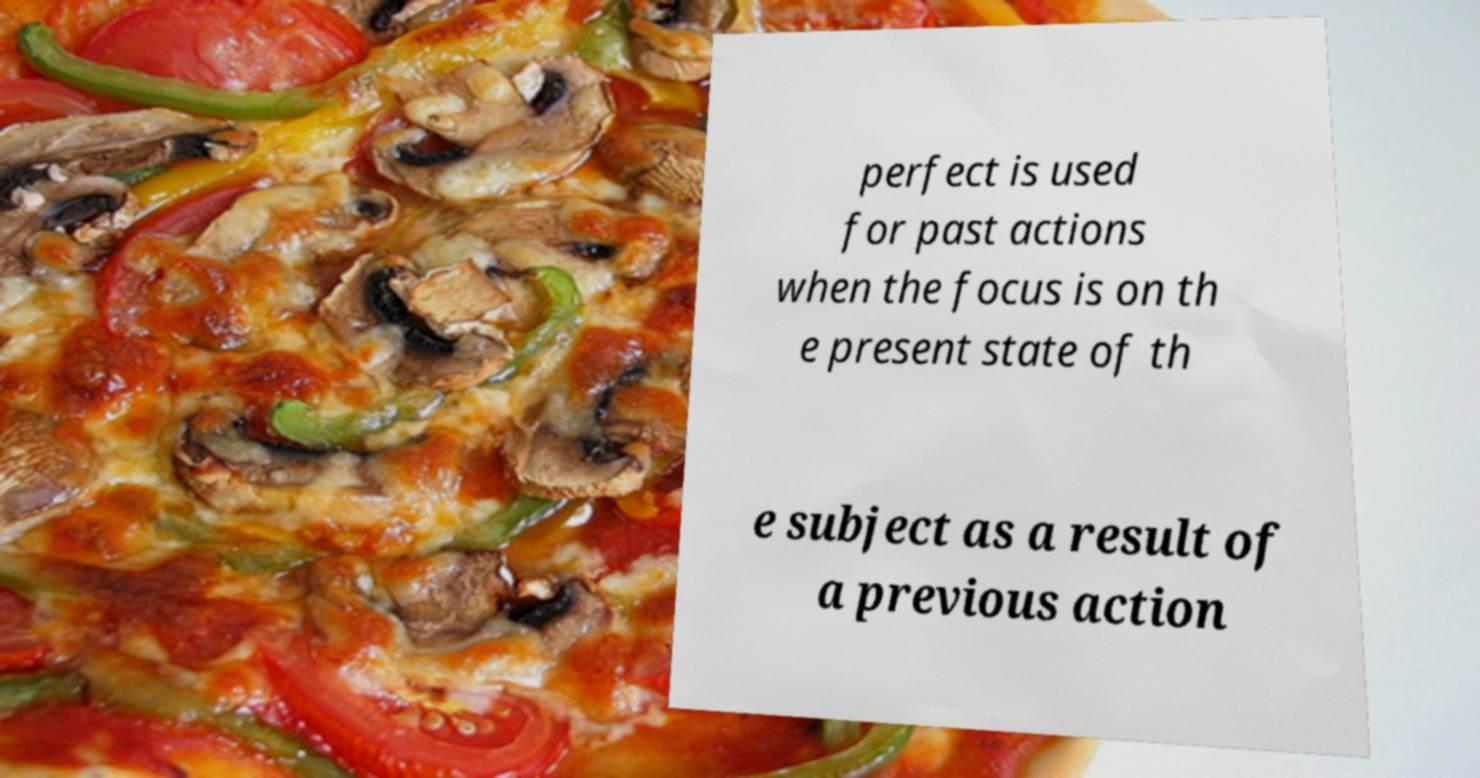There's text embedded in this image that I need extracted. Can you transcribe it verbatim? perfect is used for past actions when the focus is on th e present state of th e subject as a result of a previous action 